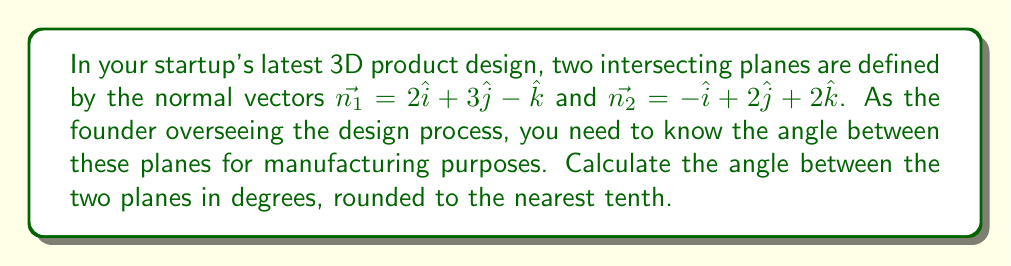Provide a solution to this math problem. To find the angle between two intersecting planes, we can use the formula:

$$\cos \theta = \frac{|\vec{n_1} \cdot \vec{n_2}|}{\|\vec{n_1}\| \|\vec{n_2}\|}$$

Where $\vec{n_1}$ and $\vec{n_2}$ are the normal vectors of the planes, $\cdot$ denotes the dot product, and $\|\vec{n}\|$ represents the magnitude of a vector.

Step 1: Calculate the dot product $\vec{n_1} \cdot \vec{n_2}$
$$\vec{n_1} \cdot \vec{n_2} = (2)(-1) + (3)(2) + (-1)(2) = -2 + 6 - 2 = 2$$

Step 2: Calculate the magnitudes of $\vec{n_1}$ and $\vec{n_2}$
$$\|\vec{n_1}\| = \sqrt{2^2 + 3^2 + (-1)^2} = \sqrt{4 + 9 + 1} = \sqrt{14}$$
$$\|\vec{n_2}\| = \sqrt{(-1)^2 + 2^2 + 2^2} = \sqrt{1 + 4 + 4} = 3$$

Step 3: Apply the formula
$$\cos \theta = \frac{|2|}{\sqrt{14} \cdot 3} = \frac{2}{3\sqrt{14}}$$

Step 4: Take the inverse cosine (arccos) of both sides
$$\theta = \arccos\left(\frac{2}{3\sqrt{14}}\right)$$

Step 5: Convert to degrees and round to the nearest tenth
$$\theta \approx 80.5^\circ$$
Answer: $80.5^\circ$ 